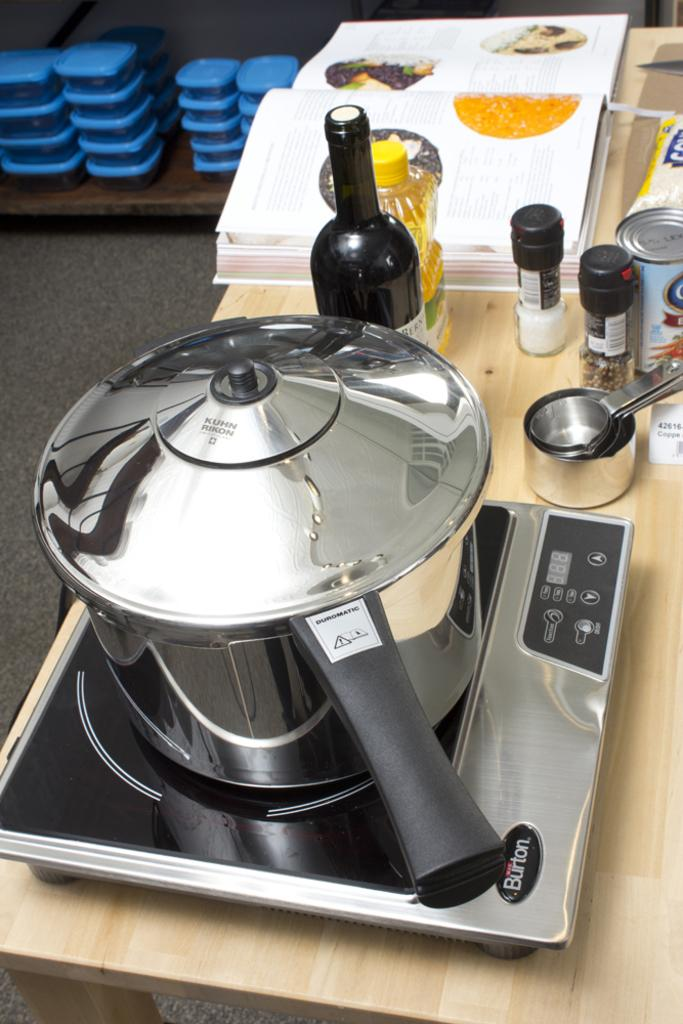<image>
Provide a brief description of the given image. A silver cooking pot on a Burton portable cooking surface is on a wooden table next to a wine bottle, spices and a cookbook. 